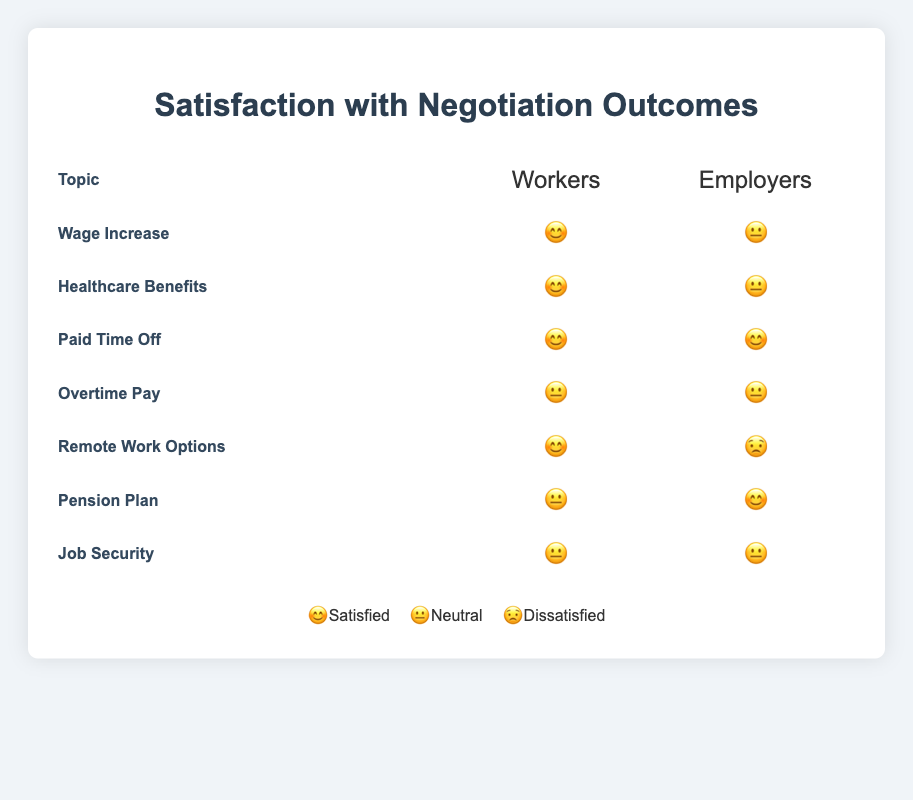What is the satisfaction level of workers regarding wage increases? Referring to the row for "Wage Increase", the satisfaction level of workers is indicated by an emoji.
Answer: 😊 Which negotiation topic has both workers and employers equally satisfied? Look for the row where the worker and employer satisfaction emojis are the same.
Answer: Paid Time Off What is the common satisfaction level of employers on healthcare benefits and wage increases? Check the rows for "Healthcare Benefits" and "Wage Increase" and identify the employer satisfaction emojis.
Answer: 😐 Which topic shows the highest dissatisfaction among employers? Find the row with the least favorable emoji for employers.
Answer: Remote Work Options How many topics show satisfied workers? Count the number of rows where the worker satisfaction emoji is 😊.
Answer: 4 Compare the satisfaction levels of workers and employers on remote work options. Who is more dissatisfied? Checking the "Remote Work Options" row, compare the emoji for worker satisfaction and employer satisfaction.
Answer: Employers Which topics show neutral satisfaction among workers? Identify rows where the worker satisfaction emoji is 😐.
Answer: Overtime Pay, Pension Plan, Job Security Which topic shows a neutral satisfaction level for both workers and employers? Find the row where both satisfaction levels are 😐.
Answer: Overtime Pay, Job Security Are there more topics with satisfied employers than with dissatisfied employers? Compare the number of rows with 😊 for employers to those with 😟.
Answer: No What are the two topics where employers are neutral but workers are satisfied? Identify rows where employer satisfaction is 😐 and worker satisfaction is 😊.
Answer: Wage Increase, Healthcare Benefits 